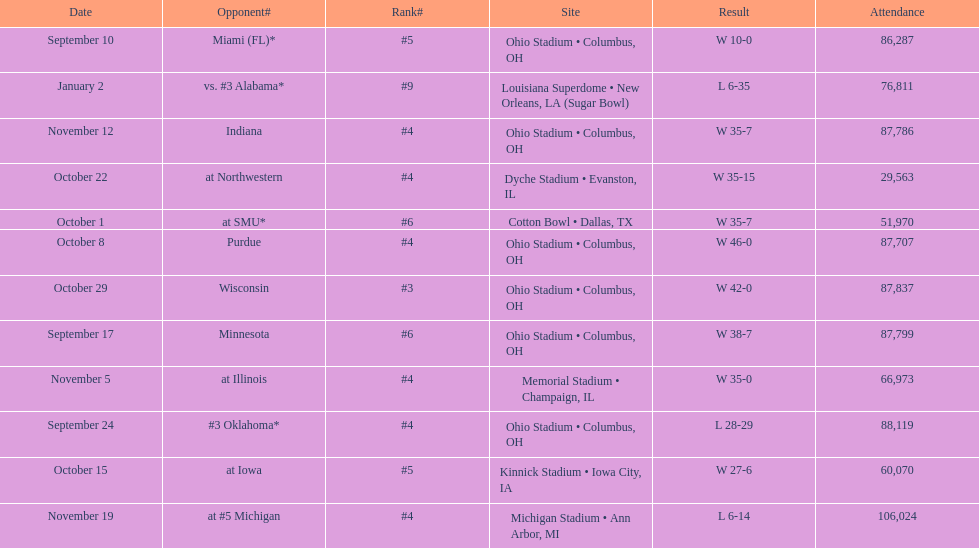How many dates are on the chart 12. 